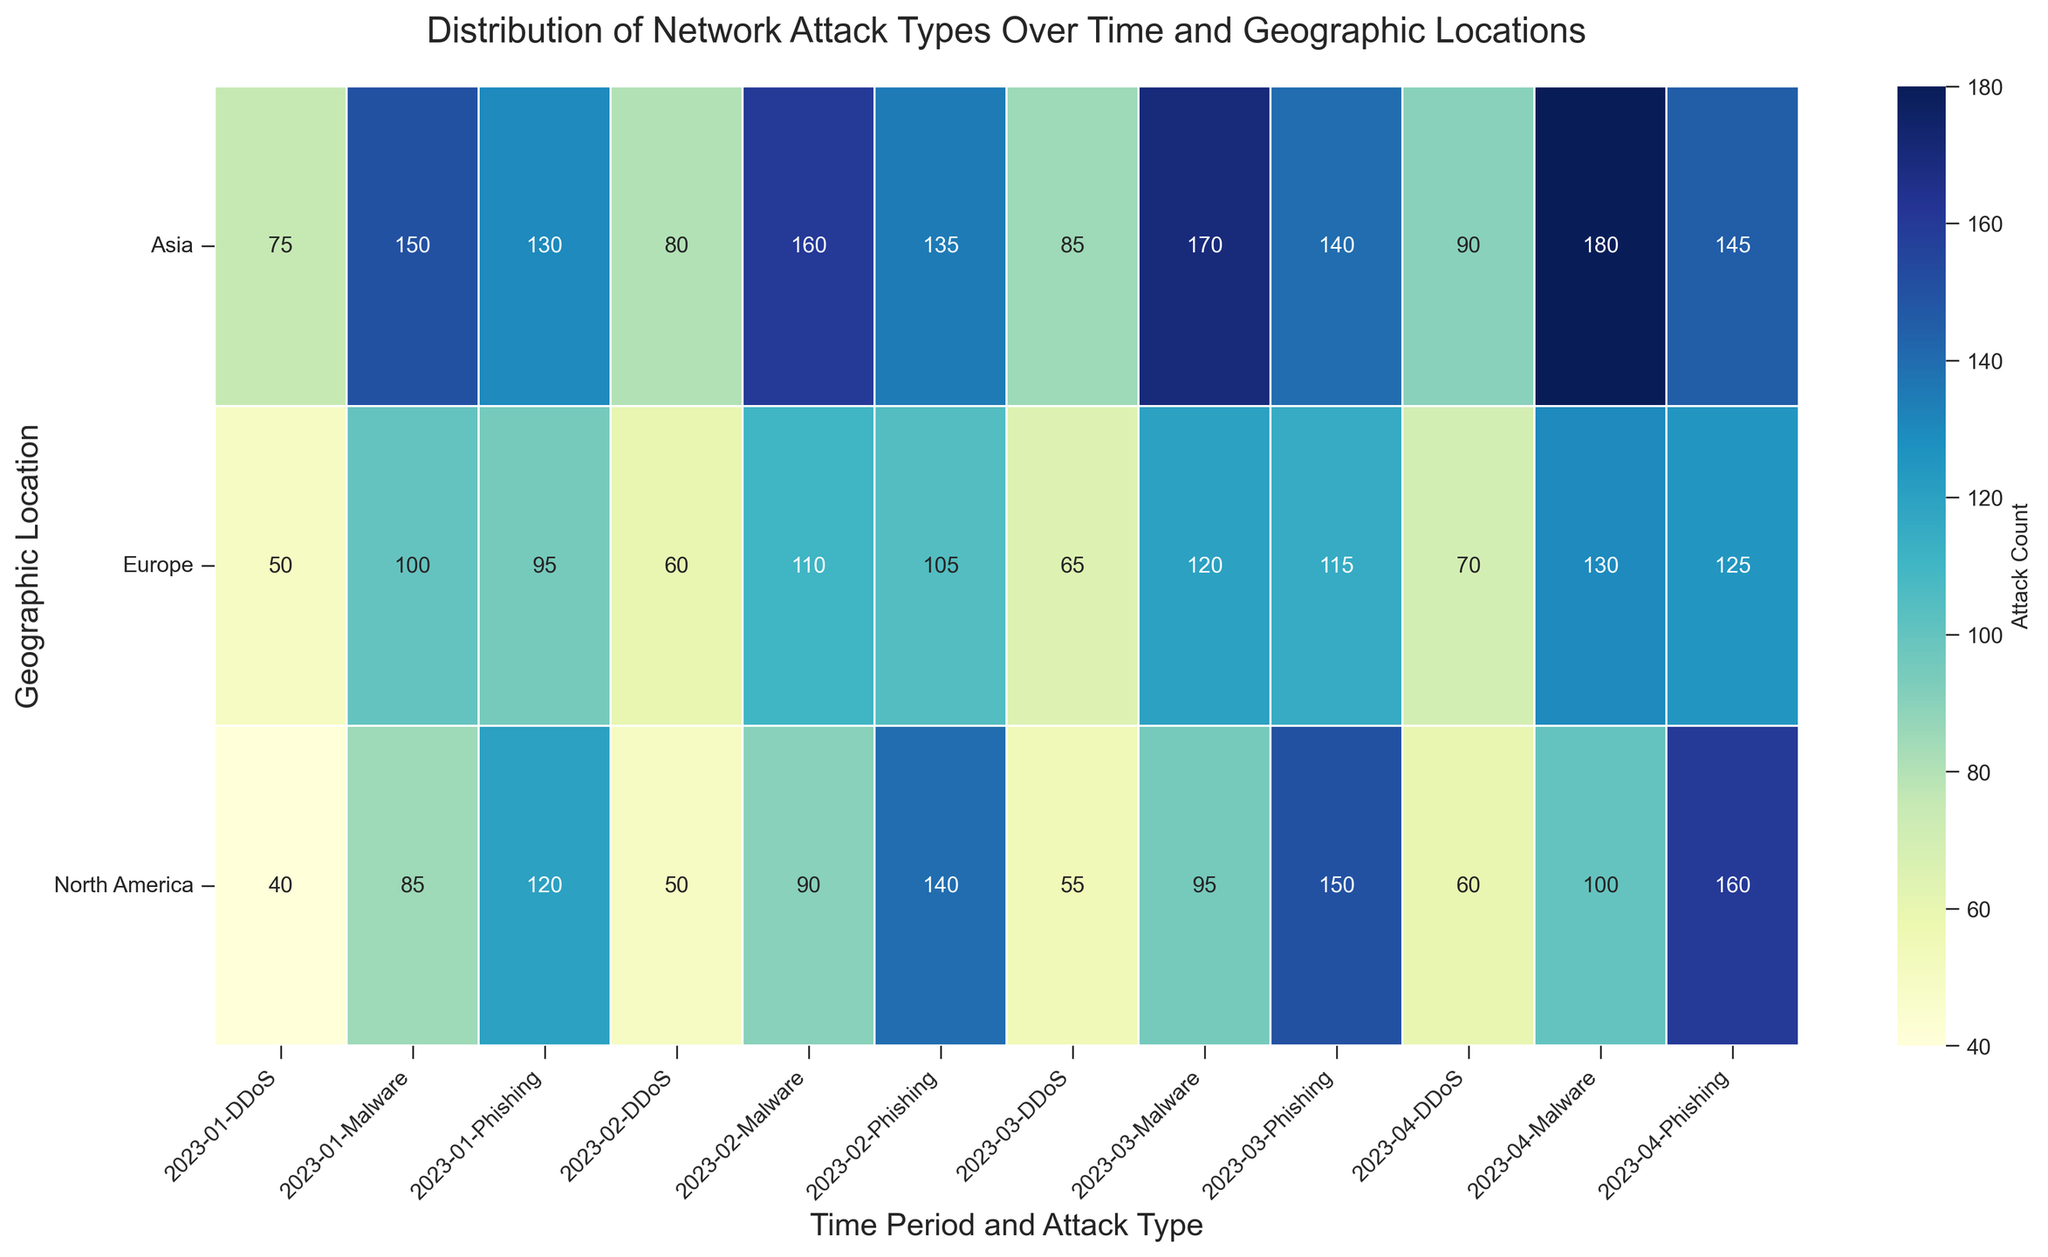What is the total number of phishing attacks in North America over the given time periods? To find the total number of phishing attacks in North America over the given time periods, sum the counts for each time period. In January: 120, February: 140, March: 150, April: 160. So, 120 + 140 + 150 + 160 = 570.
Answer: 570 Which month had the highest number of DDoS attacks in Europe and what was the count? Scan the figure to find where the DDoS attack counts for Europe are listed. Compare the counts for each month: January: 50, February: 60, March: 65, April: 70. The highest count is in April with 70 attacks.
Answer: April, 70 How does the average number of malware attacks in Asia compare to North America? First, calculate the average number of malware attacks in Asia and North America separately by summing and then dividing by the number of months. For Asia: (150 + 160 + 170 + 180) / 4 = 165. For North America: (85 + 90 + 95 + 100) / 4 = 92.5. Compare the two averages: 165 > 92.5.
Answer: Asia has a higher average What is the difference in phishing attack counts between Asia and Europe in January 2023? From the figure, identify the phishing attack counts for Asia and Europe in January 2023. Asia: 130, Europe: 95. Calculate the difference: 130 - 95 = 35.
Answer: 35 Which geographic location experienced the steepest increase in DDoS attacks from January to April? To identify the steepest increase, look at the DDoS attack counts for each region from January to April and calculate the difference. North America: 60 - 40 = 20, Europe: 70 - 50 = 20, Asia: 90 - 75 = 15. North America and Europe both have the highest increase of 20.
Answer: North America and Europe Are there any geographic locations where phishing attacks were consistently higher than malware attacks across all months? Compare the counts of phishing and malware attacks in each geographic location for all months. North America: No, Europe: No, Asia: No; In each location, the number of malware attacks was higher than phishing at least once.
Answer: No Which attack type had the most significant variation in counts across different regions for April 2023? Compare the attack counts of each type across North America, Europe, and Asia for April 2023. Phishing: 160, 125, 145. Malware: 100, 130, 180. DDoS: 60, 70, 90. The largest range (max-min) is for Malware: 180 - 100 = 80, among Phishing: 160 - 125 = 35 and DDoS: 90 - 60 = 30.
Answer: Malware What is the total number of attacks of all types combined in Asia for February 2023? Sum the attack counts of all types in Asia for February 2023. Phishing: 135, Malware: 160, DDoS: 80. So, 135 + 160 + 80 = 375.
Answer: 375 Which geographic location has the least total number of attacks in March 2023? Sum the counts of all three types of attacks for each region in March 2023. North America: 150 + 95 + 55 = 300, Europe: 115 + 120 + 65 = 300, Asia: 140 + 170 + 85 = 395. Both North America and Europe have the smallest total of 300.
Answer: North America and Europe By how much did the number of phishing attacks in Europe increase from January to April 2023? Look at the phishing attack counts for Europe in January and April 2023. January: 95, April: 125. Calculate the increase: 125 - 95 = 30.
Answer: 30 